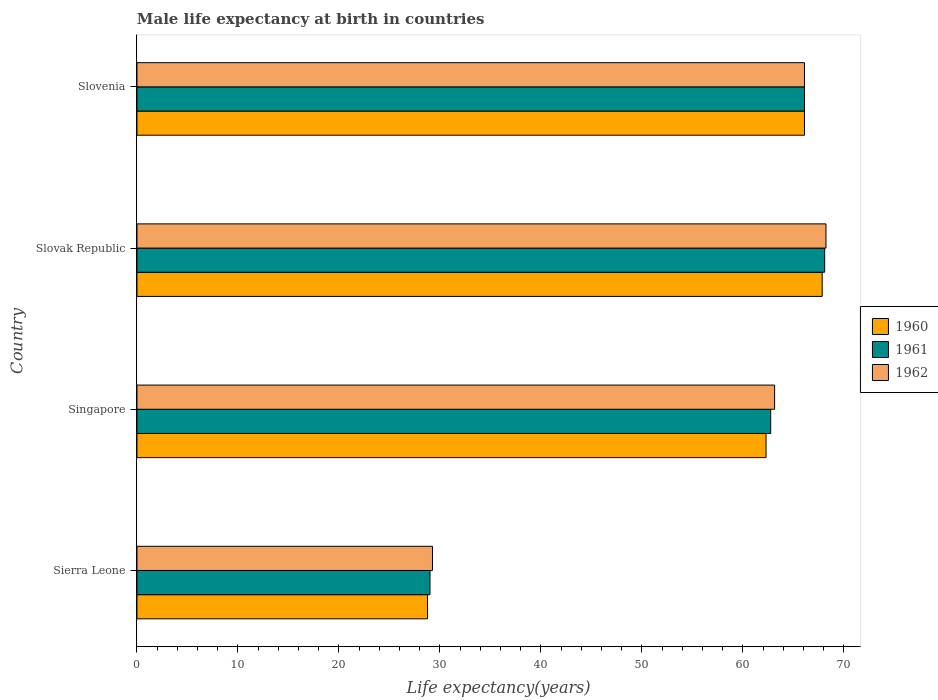How many bars are there on the 4th tick from the bottom?
Give a very brief answer. 3. What is the label of the 1st group of bars from the top?
Make the answer very short. Slovenia. What is the male life expectancy at birth in 1962 in Slovenia?
Give a very brief answer. 66.1. Across all countries, what is the maximum male life expectancy at birth in 1962?
Keep it short and to the point. 68.23. Across all countries, what is the minimum male life expectancy at birth in 1962?
Give a very brief answer. 29.26. In which country was the male life expectancy at birth in 1960 maximum?
Ensure brevity in your answer.  Slovak Republic. In which country was the male life expectancy at birth in 1961 minimum?
Provide a succinct answer. Sierra Leone. What is the total male life expectancy at birth in 1961 in the graph?
Offer a terse response. 225.97. What is the difference between the male life expectancy at birth in 1961 in Sierra Leone and that in Slovenia?
Provide a succinct answer. -37.08. What is the difference between the male life expectancy at birth in 1961 in Sierra Leone and the male life expectancy at birth in 1962 in Slovak Republic?
Offer a terse response. -39.21. What is the average male life expectancy at birth in 1962 per country?
Make the answer very short. 56.68. What is the difference between the male life expectancy at birth in 1961 and male life expectancy at birth in 1962 in Slovak Republic?
Provide a short and direct response. -0.13. In how many countries, is the male life expectancy at birth in 1961 greater than 54 years?
Your response must be concise. 3. What is the ratio of the male life expectancy at birth in 1962 in Slovak Republic to that in Slovenia?
Your response must be concise. 1.03. Is the male life expectancy at birth in 1962 in Slovak Republic less than that in Slovenia?
Offer a very short reply. No. What is the difference between the highest and the second highest male life expectancy at birth in 1960?
Your answer should be very brief. 1.75. What is the difference between the highest and the lowest male life expectancy at birth in 1962?
Offer a very short reply. 38.96. In how many countries, is the male life expectancy at birth in 1961 greater than the average male life expectancy at birth in 1961 taken over all countries?
Your answer should be compact. 3. How many bars are there?
Provide a short and direct response. 12. How many countries are there in the graph?
Keep it short and to the point. 4. What is the difference between two consecutive major ticks on the X-axis?
Provide a succinct answer. 10. Are the values on the major ticks of X-axis written in scientific E-notation?
Provide a succinct answer. No. Does the graph contain grids?
Provide a succinct answer. No. Where does the legend appear in the graph?
Offer a very short reply. Center right. How many legend labels are there?
Offer a very short reply. 3. What is the title of the graph?
Offer a very short reply. Male life expectancy at birth in countries. Does "1978" appear as one of the legend labels in the graph?
Give a very brief answer. No. What is the label or title of the X-axis?
Offer a very short reply. Life expectancy(years). What is the label or title of the Y-axis?
Give a very brief answer. Country. What is the Life expectancy(years) of 1960 in Sierra Leone?
Offer a terse response. 28.77. What is the Life expectancy(years) of 1961 in Sierra Leone?
Offer a terse response. 29.02. What is the Life expectancy(years) in 1962 in Sierra Leone?
Your answer should be very brief. 29.26. What is the Life expectancy(years) in 1960 in Singapore?
Offer a very short reply. 62.29. What is the Life expectancy(years) in 1961 in Singapore?
Give a very brief answer. 62.76. What is the Life expectancy(years) in 1962 in Singapore?
Ensure brevity in your answer.  63.14. What is the Life expectancy(years) in 1960 in Slovak Republic?
Keep it short and to the point. 67.85. What is the Life expectancy(years) in 1961 in Slovak Republic?
Offer a very short reply. 68.1. What is the Life expectancy(years) of 1962 in Slovak Republic?
Ensure brevity in your answer.  68.23. What is the Life expectancy(years) of 1960 in Slovenia?
Your answer should be compact. 66.1. What is the Life expectancy(years) of 1961 in Slovenia?
Your answer should be compact. 66.1. What is the Life expectancy(years) in 1962 in Slovenia?
Your response must be concise. 66.1. Across all countries, what is the maximum Life expectancy(years) in 1960?
Keep it short and to the point. 67.85. Across all countries, what is the maximum Life expectancy(years) in 1961?
Your response must be concise. 68.1. Across all countries, what is the maximum Life expectancy(years) of 1962?
Offer a terse response. 68.23. Across all countries, what is the minimum Life expectancy(years) of 1960?
Offer a terse response. 28.77. Across all countries, what is the minimum Life expectancy(years) of 1961?
Provide a succinct answer. 29.02. Across all countries, what is the minimum Life expectancy(years) in 1962?
Your answer should be very brief. 29.26. What is the total Life expectancy(years) in 1960 in the graph?
Your response must be concise. 225.02. What is the total Life expectancy(years) in 1961 in the graph?
Make the answer very short. 225.97. What is the total Life expectancy(years) of 1962 in the graph?
Provide a succinct answer. 226.73. What is the difference between the Life expectancy(years) in 1960 in Sierra Leone and that in Singapore?
Offer a terse response. -33.52. What is the difference between the Life expectancy(years) of 1961 in Sierra Leone and that in Singapore?
Your response must be concise. -33.74. What is the difference between the Life expectancy(years) of 1962 in Sierra Leone and that in Singapore?
Ensure brevity in your answer.  -33.88. What is the difference between the Life expectancy(years) in 1960 in Sierra Leone and that in Slovak Republic?
Offer a very short reply. -39.08. What is the difference between the Life expectancy(years) in 1961 in Sierra Leone and that in Slovak Republic?
Make the answer very short. -39.08. What is the difference between the Life expectancy(years) in 1962 in Sierra Leone and that in Slovak Republic?
Provide a succinct answer. -38.96. What is the difference between the Life expectancy(years) in 1960 in Sierra Leone and that in Slovenia?
Ensure brevity in your answer.  -37.33. What is the difference between the Life expectancy(years) of 1961 in Sierra Leone and that in Slovenia?
Offer a very short reply. -37.08. What is the difference between the Life expectancy(years) in 1962 in Sierra Leone and that in Slovenia?
Make the answer very short. -36.84. What is the difference between the Life expectancy(years) of 1960 in Singapore and that in Slovak Republic?
Provide a short and direct response. -5.56. What is the difference between the Life expectancy(years) of 1961 in Singapore and that in Slovak Republic?
Make the answer very short. -5.34. What is the difference between the Life expectancy(years) in 1962 in Singapore and that in Slovak Republic?
Keep it short and to the point. -5.09. What is the difference between the Life expectancy(years) in 1960 in Singapore and that in Slovenia?
Your answer should be very brief. -3.81. What is the difference between the Life expectancy(years) of 1961 in Singapore and that in Slovenia?
Offer a very short reply. -3.35. What is the difference between the Life expectancy(years) in 1962 in Singapore and that in Slovenia?
Offer a terse response. -2.96. What is the difference between the Life expectancy(years) of 1960 in Slovak Republic and that in Slovenia?
Offer a terse response. 1.75. What is the difference between the Life expectancy(years) of 1961 in Slovak Republic and that in Slovenia?
Provide a succinct answer. 2. What is the difference between the Life expectancy(years) of 1962 in Slovak Republic and that in Slovenia?
Your response must be concise. 2.13. What is the difference between the Life expectancy(years) of 1960 in Sierra Leone and the Life expectancy(years) of 1961 in Singapore?
Make the answer very short. -33.98. What is the difference between the Life expectancy(years) in 1960 in Sierra Leone and the Life expectancy(years) in 1962 in Singapore?
Your answer should be very brief. -34.37. What is the difference between the Life expectancy(years) of 1961 in Sierra Leone and the Life expectancy(years) of 1962 in Singapore?
Ensure brevity in your answer.  -34.12. What is the difference between the Life expectancy(years) of 1960 in Sierra Leone and the Life expectancy(years) of 1961 in Slovak Republic?
Your answer should be very brief. -39.33. What is the difference between the Life expectancy(years) in 1960 in Sierra Leone and the Life expectancy(years) in 1962 in Slovak Republic?
Make the answer very short. -39.45. What is the difference between the Life expectancy(years) of 1961 in Sierra Leone and the Life expectancy(years) of 1962 in Slovak Republic?
Provide a succinct answer. -39.21. What is the difference between the Life expectancy(years) of 1960 in Sierra Leone and the Life expectancy(years) of 1961 in Slovenia?
Offer a very short reply. -37.33. What is the difference between the Life expectancy(years) of 1960 in Sierra Leone and the Life expectancy(years) of 1962 in Slovenia?
Offer a terse response. -37.33. What is the difference between the Life expectancy(years) in 1961 in Sierra Leone and the Life expectancy(years) in 1962 in Slovenia?
Keep it short and to the point. -37.08. What is the difference between the Life expectancy(years) of 1960 in Singapore and the Life expectancy(years) of 1961 in Slovak Republic?
Offer a terse response. -5.8. What is the difference between the Life expectancy(years) of 1960 in Singapore and the Life expectancy(years) of 1962 in Slovak Republic?
Your response must be concise. -5.93. What is the difference between the Life expectancy(years) of 1961 in Singapore and the Life expectancy(years) of 1962 in Slovak Republic?
Offer a terse response. -5.47. What is the difference between the Life expectancy(years) of 1960 in Singapore and the Life expectancy(years) of 1961 in Slovenia?
Your answer should be compact. -3.81. What is the difference between the Life expectancy(years) of 1960 in Singapore and the Life expectancy(years) of 1962 in Slovenia?
Your response must be concise. -3.81. What is the difference between the Life expectancy(years) of 1961 in Singapore and the Life expectancy(years) of 1962 in Slovenia?
Your answer should be compact. -3.35. What is the difference between the Life expectancy(years) of 1960 in Slovak Republic and the Life expectancy(years) of 1961 in Slovenia?
Offer a terse response. 1.75. What is the difference between the Life expectancy(years) in 1960 in Slovak Republic and the Life expectancy(years) in 1962 in Slovenia?
Offer a very short reply. 1.75. What is the difference between the Life expectancy(years) of 1961 in Slovak Republic and the Life expectancy(years) of 1962 in Slovenia?
Provide a short and direct response. 2. What is the average Life expectancy(years) of 1960 per country?
Provide a short and direct response. 56.25. What is the average Life expectancy(years) in 1961 per country?
Your answer should be compact. 56.49. What is the average Life expectancy(years) of 1962 per country?
Provide a succinct answer. 56.68. What is the difference between the Life expectancy(years) of 1960 and Life expectancy(years) of 1961 in Sierra Leone?
Provide a short and direct response. -0.24. What is the difference between the Life expectancy(years) in 1960 and Life expectancy(years) in 1962 in Sierra Leone?
Make the answer very short. -0.49. What is the difference between the Life expectancy(years) of 1961 and Life expectancy(years) of 1962 in Sierra Leone?
Offer a terse response. -0.25. What is the difference between the Life expectancy(years) in 1960 and Life expectancy(years) in 1961 in Singapore?
Make the answer very short. -0.46. What is the difference between the Life expectancy(years) of 1960 and Life expectancy(years) of 1962 in Singapore?
Give a very brief answer. -0.85. What is the difference between the Life expectancy(years) of 1961 and Life expectancy(years) of 1962 in Singapore?
Your answer should be compact. -0.39. What is the difference between the Life expectancy(years) in 1960 and Life expectancy(years) in 1961 in Slovak Republic?
Provide a succinct answer. -0.24. What is the difference between the Life expectancy(years) of 1960 and Life expectancy(years) of 1962 in Slovak Republic?
Keep it short and to the point. -0.38. What is the difference between the Life expectancy(years) of 1961 and Life expectancy(years) of 1962 in Slovak Republic?
Your response must be concise. -0.13. What is the difference between the Life expectancy(years) in 1960 and Life expectancy(years) in 1962 in Slovenia?
Give a very brief answer. 0. What is the ratio of the Life expectancy(years) of 1960 in Sierra Leone to that in Singapore?
Make the answer very short. 0.46. What is the ratio of the Life expectancy(years) of 1961 in Sierra Leone to that in Singapore?
Offer a terse response. 0.46. What is the ratio of the Life expectancy(years) in 1962 in Sierra Leone to that in Singapore?
Your answer should be compact. 0.46. What is the ratio of the Life expectancy(years) of 1960 in Sierra Leone to that in Slovak Republic?
Your answer should be compact. 0.42. What is the ratio of the Life expectancy(years) in 1961 in Sierra Leone to that in Slovak Republic?
Make the answer very short. 0.43. What is the ratio of the Life expectancy(years) of 1962 in Sierra Leone to that in Slovak Republic?
Give a very brief answer. 0.43. What is the ratio of the Life expectancy(years) of 1960 in Sierra Leone to that in Slovenia?
Your answer should be very brief. 0.44. What is the ratio of the Life expectancy(years) in 1961 in Sierra Leone to that in Slovenia?
Offer a very short reply. 0.44. What is the ratio of the Life expectancy(years) of 1962 in Sierra Leone to that in Slovenia?
Provide a succinct answer. 0.44. What is the ratio of the Life expectancy(years) of 1960 in Singapore to that in Slovak Republic?
Offer a terse response. 0.92. What is the ratio of the Life expectancy(years) in 1961 in Singapore to that in Slovak Republic?
Give a very brief answer. 0.92. What is the ratio of the Life expectancy(years) in 1962 in Singapore to that in Slovak Republic?
Make the answer very short. 0.93. What is the ratio of the Life expectancy(years) in 1960 in Singapore to that in Slovenia?
Your answer should be compact. 0.94. What is the ratio of the Life expectancy(years) of 1961 in Singapore to that in Slovenia?
Provide a short and direct response. 0.95. What is the ratio of the Life expectancy(years) in 1962 in Singapore to that in Slovenia?
Your answer should be compact. 0.96. What is the ratio of the Life expectancy(years) in 1960 in Slovak Republic to that in Slovenia?
Your response must be concise. 1.03. What is the ratio of the Life expectancy(years) of 1961 in Slovak Republic to that in Slovenia?
Give a very brief answer. 1.03. What is the ratio of the Life expectancy(years) of 1962 in Slovak Republic to that in Slovenia?
Give a very brief answer. 1.03. What is the difference between the highest and the second highest Life expectancy(years) in 1960?
Ensure brevity in your answer.  1.75. What is the difference between the highest and the second highest Life expectancy(years) of 1961?
Offer a very short reply. 2. What is the difference between the highest and the second highest Life expectancy(years) of 1962?
Offer a very short reply. 2.13. What is the difference between the highest and the lowest Life expectancy(years) in 1960?
Give a very brief answer. 39.08. What is the difference between the highest and the lowest Life expectancy(years) of 1961?
Your answer should be compact. 39.08. What is the difference between the highest and the lowest Life expectancy(years) of 1962?
Your answer should be compact. 38.96. 